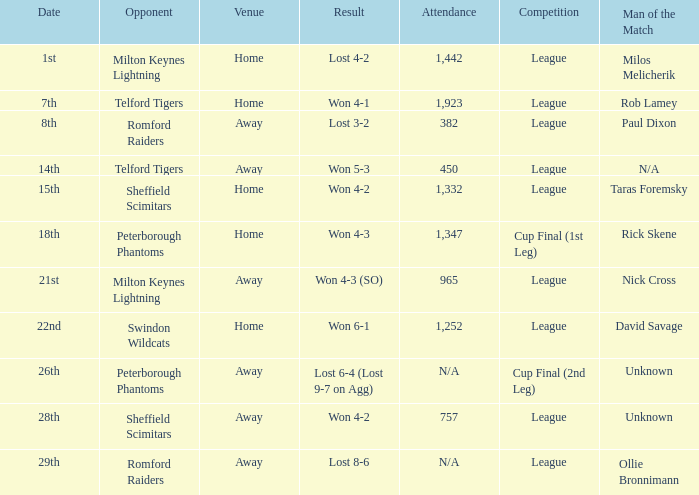Would you mind parsing the complete table? {'header': ['Date', 'Opponent', 'Venue', 'Result', 'Attendance', 'Competition', 'Man of the Match'], 'rows': [['1st', 'Milton Keynes Lightning', 'Home', 'Lost 4-2', '1,442', 'League', 'Milos Melicherik'], ['7th', 'Telford Tigers', 'Home', 'Won 4-1', '1,923', 'League', 'Rob Lamey'], ['8th', 'Romford Raiders', 'Away', 'Lost 3-2', '382', 'League', 'Paul Dixon'], ['14th', 'Telford Tigers', 'Away', 'Won 5-3', '450', 'League', 'N/A'], ['15th', 'Sheffield Scimitars', 'Home', 'Won 4-2', '1,332', 'League', 'Taras Foremsky'], ['18th', 'Peterborough Phantoms', 'Home', 'Won 4-3', '1,347', 'Cup Final (1st Leg)', 'Rick Skene'], ['21st', 'Milton Keynes Lightning', 'Away', 'Won 4-3 (SO)', '965', 'League', 'Nick Cross'], ['22nd', 'Swindon Wildcats', 'Home', 'Won 6-1', '1,252', 'League', 'David Savage'], ['26th', 'Peterborough Phantoms', 'Away', 'Lost 6-4 (Lost 9-7 on Agg)', 'N/A', 'Cup Final (2nd Leg)', 'Unknown'], ['28th', 'Sheffield Scimitars', 'Away', 'Won 4-2', '757', 'League', 'Unknown'], ['29th', 'Romford Raiders', 'Away', 'Lost 8-6', 'N/A', 'League', 'Ollie Bronnimann']]} What was the result on the 26th? Lost 6-4 (Lost 9-7 on Agg). 